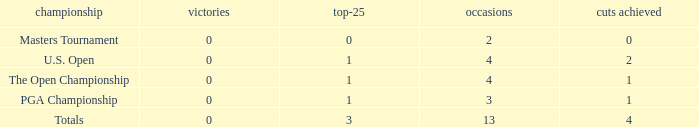How many cuts did he make at the PGA championship in 3 events? None. 